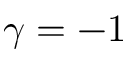<formula> <loc_0><loc_0><loc_500><loc_500>\gamma = - 1</formula> 